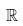<formula> <loc_0><loc_0><loc_500><loc_500>\mathbb { R }</formula> 